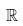<formula> <loc_0><loc_0><loc_500><loc_500>\mathbb { R }</formula> 